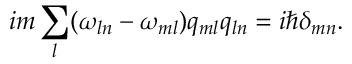Convert formula to latex. <formula><loc_0><loc_0><loc_500><loc_500>i m \sum _ { l } ( \omega _ { \ln } - \omega _ { m l } ) q _ { m l } q _ { \ln } = i \hbar { \delta } _ { m n } .</formula> 